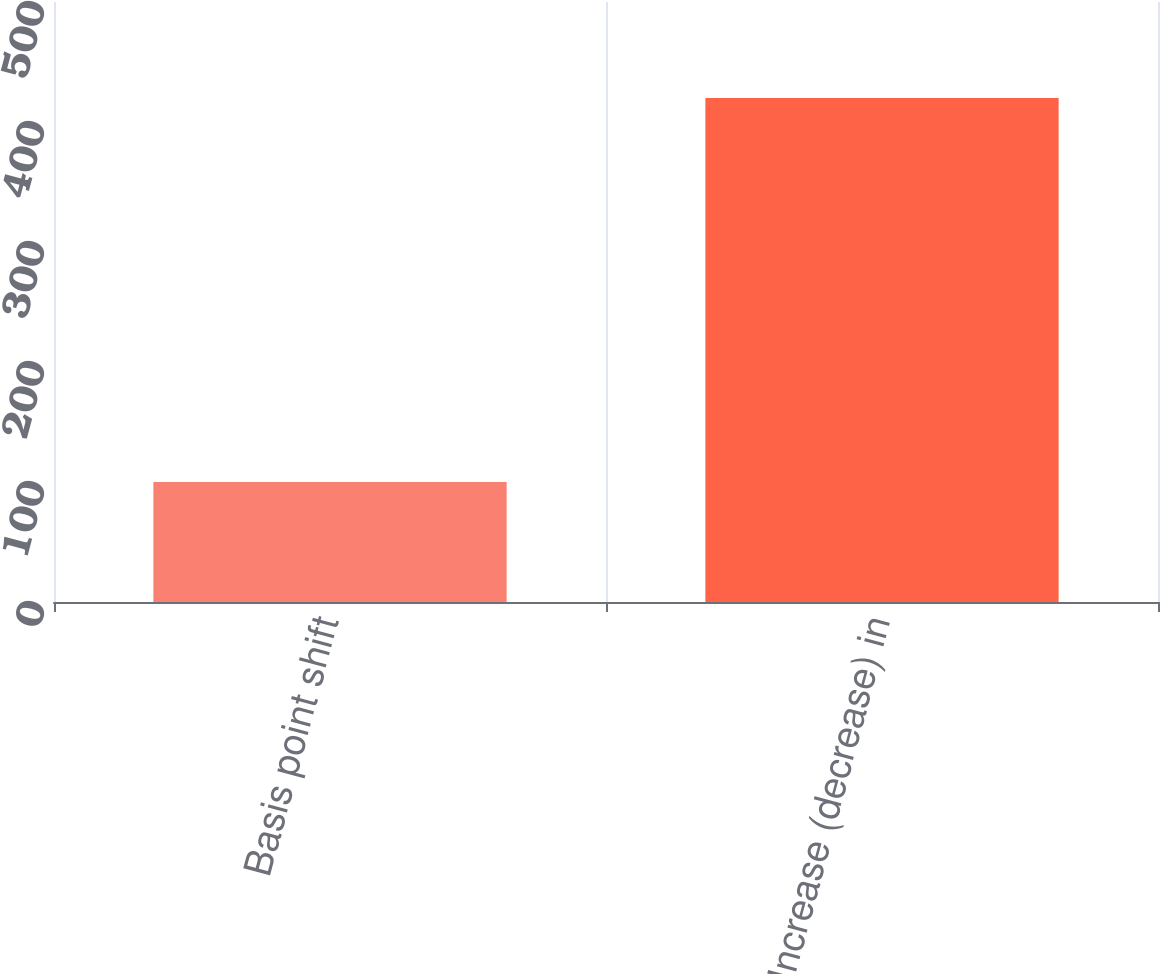Convert chart to OTSL. <chart><loc_0><loc_0><loc_500><loc_500><bar_chart><fcel>Basis point shift<fcel>Increase (decrease) in<nl><fcel>100<fcel>420<nl></chart> 